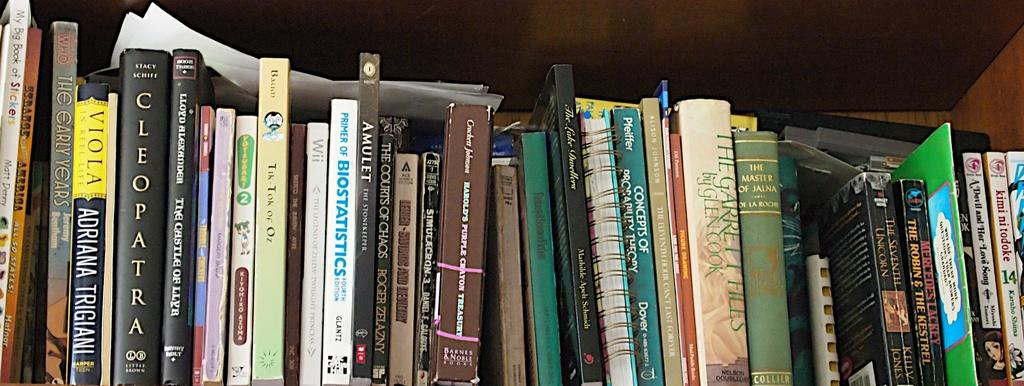<image>
Create a compact narrative representing the image presented. A disorganized bookshelf full of books has a book about Cleopatra on it. 